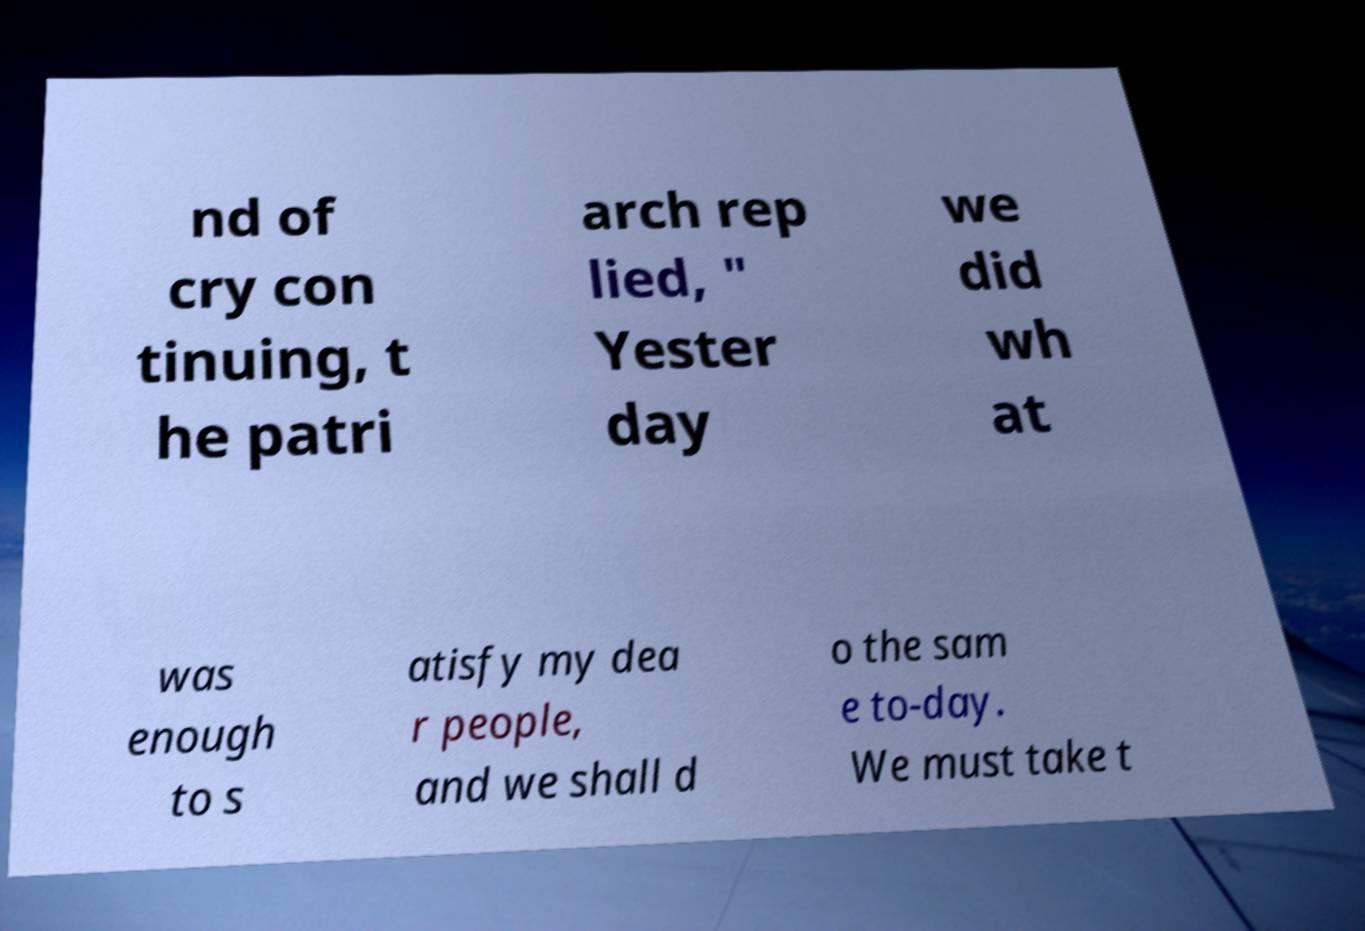Can you read and provide the text displayed in the image?This photo seems to have some interesting text. Can you extract and type it out for me? nd of cry con tinuing, t he patri arch rep lied, " Yester day we did wh at was enough to s atisfy my dea r people, and we shall d o the sam e to-day. We must take t 